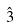Convert formula to latex. <formula><loc_0><loc_0><loc_500><loc_500>\hat { 3 }</formula> 